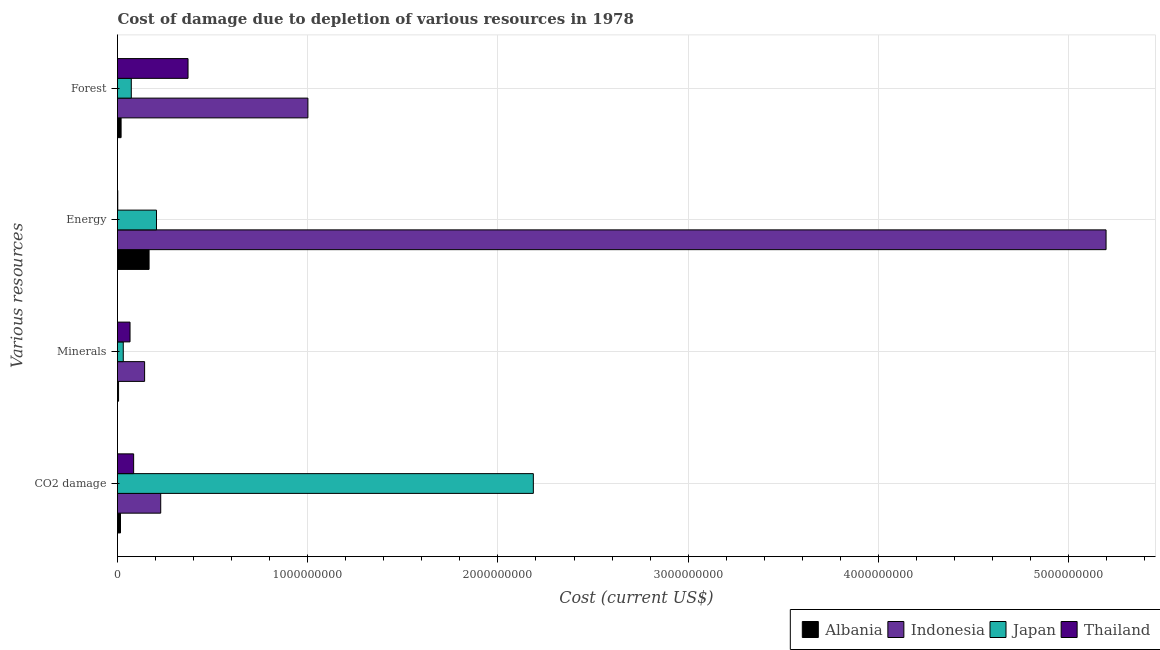How many different coloured bars are there?
Offer a very short reply. 4. Are the number of bars on each tick of the Y-axis equal?
Make the answer very short. Yes. What is the label of the 2nd group of bars from the top?
Your answer should be compact. Energy. What is the cost of damage due to depletion of energy in Albania?
Make the answer very short. 1.66e+08. Across all countries, what is the maximum cost of damage due to depletion of forests?
Your response must be concise. 1.00e+09. Across all countries, what is the minimum cost of damage due to depletion of forests?
Provide a succinct answer. 1.88e+07. In which country was the cost of damage due to depletion of coal maximum?
Make the answer very short. Japan. In which country was the cost of damage due to depletion of coal minimum?
Provide a short and direct response. Albania. What is the total cost of damage due to depletion of energy in the graph?
Give a very brief answer. 5.57e+09. What is the difference between the cost of damage due to depletion of energy in Indonesia and that in Japan?
Make the answer very short. 4.99e+09. What is the difference between the cost of damage due to depletion of forests in Japan and the cost of damage due to depletion of energy in Indonesia?
Keep it short and to the point. -5.12e+09. What is the average cost of damage due to depletion of minerals per country?
Keep it short and to the point. 6.10e+07. What is the difference between the cost of damage due to depletion of minerals and cost of damage due to depletion of forests in Albania?
Offer a terse response. -1.33e+07. What is the ratio of the cost of damage due to depletion of forests in Albania to that in Thailand?
Your answer should be very brief. 0.05. Is the difference between the cost of damage due to depletion of energy in Albania and Japan greater than the difference between the cost of damage due to depletion of forests in Albania and Japan?
Offer a terse response. Yes. What is the difference between the highest and the second highest cost of damage due to depletion of coal?
Offer a terse response. 1.96e+09. What is the difference between the highest and the lowest cost of damage due to depletion of forests?
Your answer should be very brief. 9.82e+08. Is the sum of the cost of damage due to depletion of minerals in Japan and Indonesia greater than the maximum cost of damage due to depletion of energy across all countries?
Your response must be concise. No. Is it the case that in every country, the sum of the cost of damage due to depletion of minerals and cost of damage due to depletion of coal is greater than the sum of cost of damage due to depletion of energy and cost of damage due to depletion of forests?
Offer a very short reply. No. What does the 4th bar from the bottom in Minerals represents?
Provide a short and direct response. Thailand. Is it the case that in every country, the sum of the cost of damage due to depletion of coal and cost of damage due to depletion of minerals is greater than the cost of damage due to depletion of energy?
Your response must be concise. No. How many bars are there?
Provide a short and direct response. 16. How many countries are there in the graph?
Offer a terse response. 4. Are the values on the major ticks of X-axis written in scientific E-notation?
Ensure brevity in your answer.  No. Does the graph contain any zero values?
Provide a succinct answer. No. Where does the legend appear in the graph?
Provide a short and direct response. Bottom right. What is the title of the graph?
Offer a very short reply. Cost of damage due to depletion of various resources in 1978 . Does "Guinea-Bissau" appear as one of the legend labels in the graph?
Your answer should be very brief. No. What is the label or title of the X-axis?
Ensure brevity in your answer.  Cost (current US$). What is the label or title of the Y-axis?
Your response must be concise. Various resources. What is the Cost (current US$) in Albania in CO2 damage?
Provide a short and direct response. 1.57e+07. What is the Cost (current US$) of Indonesia in CO2 damage?
Offer a very short reply. 2.27e+08. What is the Cost (current US$) in Japan in CO2 damage?
Your answer should be compact. 2.19e+09. What is the Cost (current US$) in Thailand in CO2 damage?
Offer a terse response. 8.48e+07. What is the Cost (current US$) in Albania in Minerals?
Keep it short and to the point. 5.53e+06. What is the Cost (current US$) in Indonesia in Minerals?
Offer a terse response. 1.43e+08. What is the Cost (current US$) in Japan in Minerals?
Ensure brevity in your answer.  3.03e+07. What is the Cost (current US$) of Thailand in Minerals?
Offer a very short reply. 6.58e+07. What is the Cost (current US$) in Albania in Energy?
Provide a short and direct response. 1.66e+08. What is the Cost (current US$) in Indonesia in Energy?
Keep it short and to the point. 5.20e+09. What is the Cost (current US$) of Japan in Energy?
Your response must be concise. 2.05e+08. What is the Cost (current US$) of Thailand in Energy?
Ensure brevity in your answer.  1.40e+06. What is the Cost (current US$) in Albania in Forest?
Provide a short and direct response. 1.88e+07. What is the Cost (current US$) of Indonesia in Forest?
Your answer should be compact. 1.00e+09. What is the Cost (current US$) in Japan in Forest?
Make the answer very short. 7.25e+07. What is the Cost (current US$) of Thailand in Forest?
Ensure brevity in your answer.  3.71e+08. Across all Various resources, what is the maximum Cost (current US$) of Albania?
Ensure brevity in your answer.  1.66e+08. Across all Various resources, what is the maximum Cost (current US$) in Indonesia?
Make the answer very short. 5.20e+09. Across all Various resources, what is the maximum Cost (current US$) of Japan?
Your response must be concise. 2.19e+09. Across all Various resources, what is the maximum Cost (current US$) of Thailand?
Make the answer very short. 3.71e+08. Across all Various resources, what is the minimum Cost (current US$) of Albania?
Make the answer very short. 5.53e+06. Across all Various resources, what is the minimum Cost (current US$) of Indonesia?
Keep it short and to the point. 1.43e+08. Across all Various resources, what is the minimum Cost (current US$) in Japan?
Your answer should be very brief. 3.03e+07. Across all Various resources, what is the minimum Cost (current US$) of Thailand?
Make the answer very short. 1.40e+06. What is the total Cost (current US$) in Albania in the graph?
Give a very brief answer. 2.06e+08. What is the total Cost (current US$) of Indonesia in the graph?
Make the answer very short. 6.57e+09. What is the total Cost (current US$) in Japan in the graph?
Make the answer very short. 2.49e+09. What is the total Cost (current US$) of Thailand in the graph?
Offer a terse response. 5.23e+08. What is the difference between the Cost (current US$) of Albania in CO2 damage and that in Minerals?
Give a very brief answer. 1.02e+07. What is the difference between the Cost (current US$) in Indonesia in CO2 damage and that in Minerals?
Your answer should be compact. 8.47e+07. What is the difference between the Cost (current US$) in Japan in CO2 damage and that in Minerals?
Keep it short and to the point. 2.16e+09. What is the difference between the Cost (current US$) in Thailand in CO2 damage and that in Minerals?
Make the answer very short. 1.90e+07. What is the difference between the Cost (current US$) of Albania in CO2 damage and that in Energy?
Your answer should be compact. -1.50e+08. What is the difference between the Cost (current US$) in Indonesia in CO2 damage and that in Energy?
Offer a very short reply. -4.97e+09. What is the difference between the Cost (current US$) in Japan in CO2 damage and that in Energy?
Offer a very short reply. 1.98e+09. What is the difference between the Cost (current US$) in Thailand in CO2 damage and that in Energy?
Ensure brevity in your answer.  8.34e+07. What is the difference between the Cost (current US$) in Albania in CO2 damage and that in Forest?
Offer a terse response. -3.13e+06. What is the difference between the Cost (current US$) in Indonesia in CO2 damage and that in Forest?
Provide a short and direct response. -7.74e+08. What is the difference between the Cost (current US$) of Japan in CO2 damage and that in Forest?
Give a very brief answer. 2.11e+09. What is the difference between the Cost (current US$) of Thailand in CO2 damage and that in Forest?
Make the answer very short. -2.86e+08. What is the difference between the Cost (current US$) of Albania in Minerals and that in Energy?
Offer a terse response. -1.60e+08. What is the difference between the Cost (current US$) of Indonesia in Minerals and that in Energy?
Keep it short and to the point. -5.05e+09. What is the difference between the Cost (current US$) in Japan in Minerals and that in Energy?
Provide a succinct answer. -1.75e+08. What is the difference between the Cost (current US$) in Thailand in Minerals and that in Energy?
Make the answer very short. 6.44e+07. What is the difference between the Cost (current US$) of Albania in Minerals and that in Forest?
Give a very brief answer. -1.33e+07. What is the difference between the Cost (current US$) of Indonesia in Minerals and that in Forest?
Keep it short and to the point. -8.58e+08. What is the difference between the Cost (current US$) of Japan in Minerals and that in Forest?
Make the answer very short. -4.22e+07. What is the difference between the Cost (current US$) in Thailand in Minerals and that in Forest?
Make the answer very short. -3.05e+08. What is the difference between the Cost (current US$) of Albania in Energy and that in Forest?
Give a very brief answer. 1.47e+08. What is the difference between the Cost (current US$) of Indonesia in Energy and that in Forest?
Give a very brief answer. 4.20e+09. What is the difference between the Cost (current US$) of Japan in Energy and that in Forest?
Your response must be concise. 1.32e+08. What is the difference between the Cost (current US$) of Thailand in Energy and that in Forest?
Provide a succinct answer. -3.69e+08. What is the difference between the Cost (current US$) of Albania in CO2 damage and the Cost (current US$) of Indonesia in Minerals?
Offer a very short reply. -1.27e+08. What is the difference between the Cost (current US$) of Albania in CO2 damage and the Cost (current US$) of Japan in Minerals?
Provide a succinct answer. -1.46e+07. What is the difference between the Cost (current US$) in Albania in CO2 damage and the Cost (current US$) in Thailand in Minerals?
Offer a very short reply. -5.01e+07. What is the difference between the Cost (current US$) in Indonesia in CO2 damage and the Cost (current US$) in Japan in Minerals?
Make the answer very short. 1.97e+08. What is the difference between the Cost (current US$) of Indonesia in CO2 damage and the Cost (current US$) of Thailand in Minerals?
Your response must be concise. 1.61e+08. What is the difference between the Cost (current US$) in Japan in CO2 damage and the Cost (current US$) in Thailand in Minerals?
Provide a succinct answer. 2.12e+09. What is the difference between the Cost (current US$) of Albania in CO2 damage and the Cost (current US$) of Indonesia in Energy?
Keep it short and to the point. -5.18e+09. What is the difference between the Cost (current US$) of Albania in CO2 damage and the Cost (current US$) of Japan in Energy?
Give a very brief answer. -1.89e+08. What is the difference between the Cost (current US$) of Albania in CO2 damage and the Cost (current US$) of Thailand in Energy?
Make the answer very short. 1.43e+07. What is the difference between the Cost (current US$) in Indonesia in CO2 damage and the Cost (current US$) in Japan in Energy?
Keep it short and to the point. 2.23e+07. What is the difference between the Cost (current US$) in Indonesia in CO2 damage and the Cost (current US$) in Thailand in Energy?
Your answer should be very brief. 2.26e+08. What is the difference between the Cost (current US$) of Japan in CO2 damage and the Cost (current US$) of Thailand in Energy?
Your response must be concise. 2.18e+09. What is the difference between the Cost (current US$) in Albania in CO2 damage and the Cost (current US$) in Indonesia in Forest?
Keep it short and to the point. -9.85e+08. What is the difference between the Cost (current US$) of Albania in CO2 damage and the Cost (current US$) of Japan in Forest?
Provide a short and direct response. -5.68e+07. What is the difference between the Cost (current US$) of Albania in CO2 damage and the Cost (current US$) of Thailand in Forest?
Your response must be concise. -3.55e+08. What is the difference between the Cost (current US$) in Indonesia in CO2 damage and the Cost (current US$) in Japan in Forest?
Keep it short and to the point. 1.55e+08. What is the difference between the Cost (current US$) in Indonesia in CO2 damage and the Cost (current US$) in Thailand in Forest?
Ensure brevity in your answer.  -1.44e+08. What is the difference between the Cost (current US$) of Japan in CO2 damage and the Cost (current US$) of Thailand in Forest?
Offer a very short reply. 1.82e+09. What is the difference between the Cost (current US$) of Albania in Minerals and the Cost (current US$) of Indonesia in Energy?
Ensure brevity in your answer.  -5.19e+09. What is the difference between the Cost (current US$) of Albania in Minerals and the Cost (current US$) of Japan in Energy?
Make the answer very short. -1.99e+08. What is the difference between the Cost (current US$) of Albania in Minerals and the Cost (current US$) of Thailand in Energy?
Keep it short and to the point. 4.12e+06. What is the difference between the Cost (current US$) of Indonesia in Minerals and the Cost (current US$) of Japan in Energy?
Make the answer very short. -6.24e+07. What is the difference between the Cost (current US$) in Indonesia in Minerals and the Cost (current US$) in Thailand in Energy?
Offer a terse response. 1.41e+08. What is the difference between the Cost (current US$) of Japan in Minerals and the Cost (current US$) of Thailand in Energy?
Offer a terse response. 2.89e+07. What is the difference between the Cost (current US$) of Albania in Minerals and the Cost (current US$) of Indonesia in Forest?
Offer a terse response. -9.95e+08. What is the difference between the Cost (current US$) of Albania in Minerals and the Cost (current US$) of Japan in Forest?
Provide a succinct answer. -6.70e+07. What is the difference between the Cost (current US$) of Albania in Minerals and the Cost (current US$) of Thailand in Forest?
Your answer should be very brief. -3.65e+08. What is the difference between the Cost (current US$) in Indonesia in Minerals and the Cost (current US$) in Japan in Forest?
Your response must be concise. 7.00e+07. What is the difference between the Cost (current US$) in Indonesia in Minerals and the Cost (current US$) in Thailand in Forest?
Provide a short and direct response. -2.28e+08. What is the difference between the Cost (current US$) of Japan in Minerals and the Cost (current US$) of Thailand in Forest?
Ensure brevity in your answer.  -3.40e+08. What is the difference between the Cost (current US$) in Albania in Energy and the Cost (current US$) in Indonesia in Forest?
Offer a very short reply. -8.35e+08. What is the difference between the Cost (current US$) of Albania in Energy and the Cost (current US$) of Japan in Forest?
Your answer should be very brief. 9.35e+07. What is the difference between the Cost (current US$) in Albania in Energy and the Cost (current US$) in Thailand in Forest?
Ensure brevity in your answer.  -2.05e+08. What is the difference between the Cost (current US$) in Indonesia in Energy and the Cost (current US$) in Japan in Forest?
Keep it short and to the point. 5.12e+09. What is the difference between the Cost (current US$) of Indonesia in Energy and the Cost (current US$) of Thailand in Forest?
Offer a terse response. 4.83e+09. What is the difference between the Cost (current US$) in Japan in Energy and the Cost (current US$) in Thailand in Forest?
Offer a very short reply. -1.66e+08. What is the average Cost (current US$) of Albania per Various resources?
Your answer should be very brief. 5.15e+07. What is the average Cost (current US$) in Indonesia per Various resources?
Ensure brevity in your answer.  1.64e+09. What is the average Cost (current US$) of Japan per Various resources?
Provide a short and direct response. 6.23e+08. What is the average Cost (current US$) in Thailand per Various resources?
Offer a very short reply. 1.31e+08. What is the difference between the Cost (current US$) in Albania and Cost (current US$) in Indonesia in CO2 damage?
Ensure brevity in your answer.  -2.11e+08. What is the difference between the Cost (current US$) of Albania and Cost (current US$) of Japan in CO2 damage?
Keep it short and to the point. -2.17e+09. What is the difference between the Cost (current US$) of Albania and Cost (current US$) of Thailand in CO2 damage?
Your answer should be compact. -6.91e+07. What is the difference between the Cost (current US$) of Indonesia and Cost (current US$) of Japan in CO2 damage?
Give a very brief answer. -1.96e+09. What is the difference between the Cost (current US$) in Indonesia and Cost (current US$) in Thailand in CO2 damage?
Offer a very short reply. 1.42e+08. What is the difference between the Cost (current US$) in Japan and Cost (current US$) in Thailand in CO2 damage?
Give a very brief answer. 2.10e+09. What is the difference between the Cost (current US$) of Albania and Cost (current US$) of Indonesia in Minerals?
Ensure brevity in your answer.  -1.37e+08. What is the difference between the Cost (current US$) in Albania and Cost (current US$) in Japan in Minerals?
Give a very brief answer. -2.48e+07. What is the difference between the Cost (current US$) in Albania and Cost (current US$) in Thailand in Minerals?
Offer a terse response. -6.03e+07. What is the difference between the Cost (current US$) in Indonesia and Cost (current US$) in Japan in Minerals?
Keep it short and to the point. 1.12e+08. What is the difference between the Cost (current US$) in Indonesia and Cost (current US$) in Thailand in Minerals?
Ensure brevity in your answer.  7.67e+07. What is the difference between the Cost (current US$) in Japan and Cost (current US$) in Thailand in Minerals?
Provide a short and direct response. -3.55e+07. What is the difference between the Cost (current US$) of Albania and Cost (current US$) of Indonesia in Energy?
Keep it short and to the point. -5.03e+09. What is the difference between the Cost (current US$) of Albania and Cost (current US$) of Japan in Energy?
Provide a succinct answer. -3.89e+07. What is the difference between the Cost (current US$) in Albania and Cost (current US$) in Thailand in Energy?
Offer a very short reply. 1.65e+08. What is the difference between the Cost (current US$) of Indonesia and Cost (current US$) of Japan in Energy?
Your response must be concise. 4.99e+09. What is the difference between the Cost (current US$) of Indonesia and Cost (current US$) of Thailand in Energy?
Your answer should be very brief. 5.20e+09. What is the difference between the Cost (current US$) of Japan and Cost (current US$) of Thailand in Energy?
Your response must be concise. 2.04e+08. What is the difference between the Cost (current US$) in Albania and Cost (current US$) in Indonesia in Forest?
Your response must be concise. -9.82e+08. What is the difference between the Cost (current US$) in Albania and Cost (current US$) in Japan in Forest?
Your answer should be compact. -5.37e+07. What is the difference between the Cost (current US$) of Albania and Cost (current US$) of Thailand in Forest?
Keep it short and to the point. -3.52e+08. What is the difference between the Cost (current US$) of Indonesia and Cost (current US$) of Japan in Forest?
Give a very brief answer. 9.28e+08. What is the difference between the Cost (current US$) of Indonesia and Cost (current US$) of Thailand in Forest?
Offer a terse response. 6.30e+08. What is the difference between the Cost (current US$) in Japan and Cost (current US$) in Thailand in Forest?
Give a very brief answer. -2.98e+08. What is the ratio of the Cost (current US$) in Albania in CO2 damage to that in Minerals?
Your response must be concise. 2.84. What is the ratio of the Cost (current US$) in Indonesia in CO2 damage to that in Minerals?
Offer a very short reply. 1.59. What is the ratio of the Cost (current US$) in Japan in CO2 damage to that in Minerals?
Ensure brevity in your answer.  72.18. What is the ratio of the Cost (current US$) of Thailand in CO2 damage to that in Minerals?
Give a very brief answer. 1.29. What is the ratio of the Cost (current US$) of Albania in CO2 damage to that in Energy?
Your answer should be compact. 0.09. What is the ratio of the Cost (current US$) in Indonesia in CO2 damage to that in Energy?
Offer a terse response. 0.04. What is the ratio of the Cost (current US$) of Japan in CO2 damage to that in Energy?
Ensure brevity in your answer.  10.67. What is the ratio of the Cost (current US$) of Thailand in CO2 damage to that in Energy?
Offer a very short reply. 60.51. What is the ratio of the Cost (current US$) in Albania in CO2 damage to that in Forest?
Ensure brevity in your answer.  0.83. What is the ratio of the Cost (current US$) of Indonesia in CO2 damage to that in Forest?
Keep it short and to the point. 0.23. What is the ratio of the Cost (current US$) in Japan in CO2 damage to that in Forest?
Your answer should be very brief. 30.14. What is the ratio of the Cost (current US$) in Thailand in CO2 damage to that in Forest?
Your response must be concise. 0.23. What is the ratio of the Cost (current US$) in Indonesia in Minerals to that in Energy?
Give a very brief answer. 0.03. What is the ratio of the Cost (current US$) of Japan in Minerals to that in Energy?
Provide a short and direct response. 0.15. What is the ratio of the Cost (current US$) of Thailand in Minerals to that in Energy?
Offer a very short reply. 46.96. What is the ratio of the Cost (current US$) of Albania in Minerals to that in Forest?
Your answer should be compact. 0.29. What is the ratio of the Cost (current US$) in Indonesia in Minerals to that in Forest?
Offer a very short reply. 0.14. What is the ratio of the Cost (current US$) in Japan in Minerals to that in Forest?
Offer a terse response. 0.42. What is the ratio of the Cost (current US$) of Thailand in Minerals to that in Forest?
Provide a succinct answer. 0.18. What is the ratio of the Cost (current US$) in Albania in Energy to that in Forest?
Offer a very short reply. 8.81. What is the ratio of the Cost (current US$) in Indonesia in Energy to that in Forest?
Provide a succinct answer. 5.19. What is the ratio of the Cost (current US$) of Japan in Energy to that in Forest?
Provide a short and direct response. 2.82. What is the ratio of the Cost (current US$) in Thailand in Energy to that in Forest?
Give a very brief answer. 0. What is the difference between the highest and the second highest Cost (current US$) of Albania?
Offer a very short reply. 1.47e+08. What is the difference between the highest and the second highest Cost (current US$) in Indonesia?
Give a very brief answer. 4.20e+09. What is the difference between the highest and the second highest Cost (current US$) of Japan?
Provide a short and direct response. 1.98e+09. What is the difference between the highest and the second highest Cost (current US$) of Thailand?
Offer a terse response. 2.86e+08. What is the difference between the highest and the lowest Cost (current US$) of Albania?
Your answer should be very brief. 1.60e+08. What is the difference between the highest and the lowest Cost (current US$) in Indonesia?
Provide a short and direct response. 5.05e+09. What is the difference between the highest and the lowest Cost (current US$) of Japan?
Your answer should be compact. 2.16e+09. What is the difference between the highest and the lowest Cost (current US$) of Thailand?
Ensure brevity in your answer.  3.69e+08. 